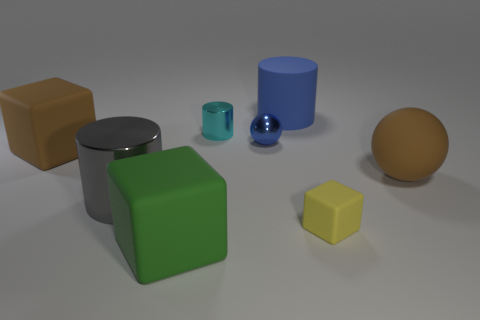How many big things are blue metallic spheres or yellow rubber balls?
Ensure brevity in your answer.  0. There is a blue thing that is the same material as the large gray thing; what is its shape?
Keep it short and to the point. Sphere. Does the large blue thing have the same shape as the cyan object?
Provide a succinct answer. Yes. What is the color of the large matte ball?
Make the answer very short. Brown. What number of objects are either small balls or tiny cylinders?
Offer a terse response. 2. Is the number of cubes in front of the green thing less than the number of small cyan cylinders?
Keep it short and to the point. Yes. Is the number of cylinders that are in front of the tiny metal cylinder greater than the number of small rubber cubes to the right of the yellow block?
Your answer should be very brief. Yes. Is there anything else that has the same color as the large metallic cylinder?
Make the answer very short. No. There is a brown object that is to the right of the cyan metal thing; what is its material?
Ensure brevity in your answer.  Rubber. Do the green thing and the brown rubber sphere have the same size?
Your answer should be compact. Yes. 